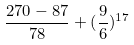Convert formula to latex. <formula><loc_0><loc_0><loc_500><loc_500>\frac { 2 7 0 - 8 7 } { 7 8 } + ( \frac { 9 } { 6 } ) ^ { 1 7 }</formula> 